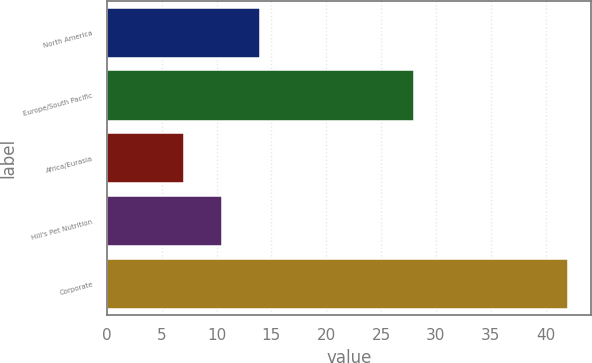<chart> <loc_0><loc_0><loc_500><loc_500><bar_chart><fcel>North America<fcel>Europe/South Pacific<fcel>Africa/Eurasia<fcel>Hill's Pet Nutrition<fcel>Corporate<nl><fcel>14<fcel>28<fcel>7<fcel>10.5<fcel>42<nl></chart> 